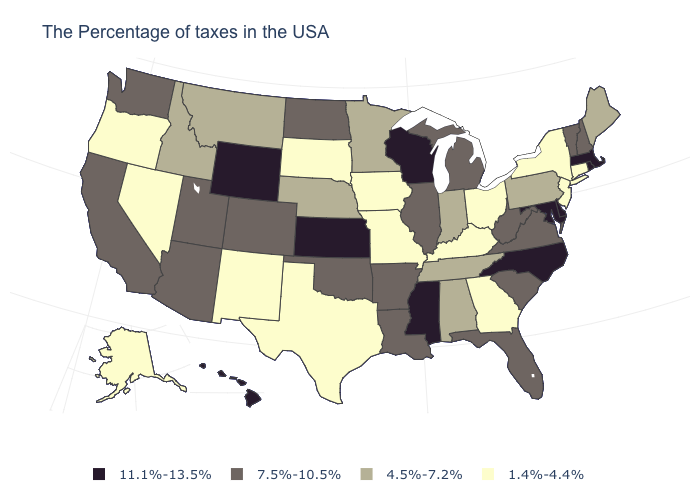Name the states that have a value in the range 7.5%-10.5%?
Give a very brief answer. New Hampshire, Vermont, Virginia, South Carolina, West Virginia, Florida, Michigan, Illinois, Louisiana, Arkansas, Oklahoma, North Dakota, Colorado, Utah, Arizona, California, Washington. Is the legend a continuous bar?
Keep it brief. No. Name the states that have a value in the range 4.5%-7.2%?
Answer briefly. Maine, Pennsylvania, Indiana, Alabama, Tennessee, Minnesota, Nebraska, Montana, Idaho. What is the value of Kentucky?
Be succinct. 1.4%-4.4%. What is the value of Massachusetts?
Answer briefly. 11.1%-13.5%. What is the value of New York?
Be succinct. 1.4%-4.4%. Name the states that have a value in the range 1.4%-4.4%?
Short answer required. Connecticut, New York, New Jersey, Ohio, Georgia, Kentucky, Missouri, Iowa, Texas, South Dakota, New Mexico, Nevada, Oregon, Alaska. What is the value of Iowa?
Be succinct. 1.4%-4.4%. Among the states that border Arkansas , does Mississippi have the lowest value?
Give a very brief answer. No. Which states have the lowest value in the MidWest?
Write a very short answer. Ohio, Missouri, Iowa, South Dakota. Name the states that have a value in the range 4.5%-7.2%?
Answer briefly. Maine, Pennsylvania, Indiana, Alabama, Tennessee, Minnesota, Nebraska, Montana, Idaho. Which states have the highest value in the USA?
Concise answer only. Massachusetts, Rhode Island, Delaware, Maryland, North Carolina, Wisconsin, Mississippi, Kansas, Wyoming, Hawaii. What is the value of New York?
Give a very brief answer. 1.4%-4.4%. What is the value of Ohio?
Write a very short answer. 1.4%-4.4%. 